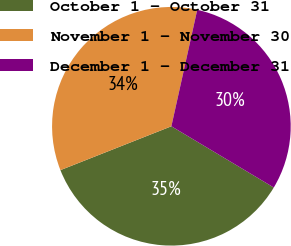Convert chart to OTSL. <chart><loc_0><loc_0><loc_500><loc_500><pie_chart><fcel>October 1 - October 31<fcel>November 1 - November 30<fcel>December 1 - December 31<nl><fcel>35.43%<fcel>34.47%<fcel>30.1%<nl></chart> 